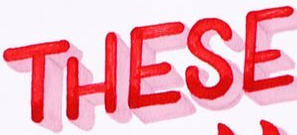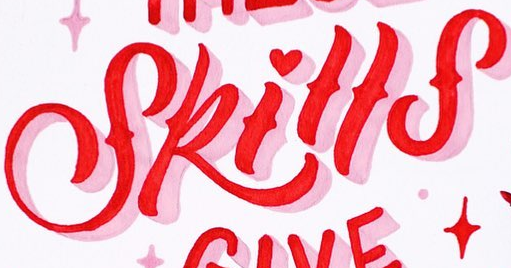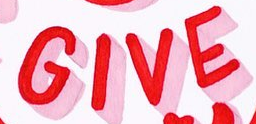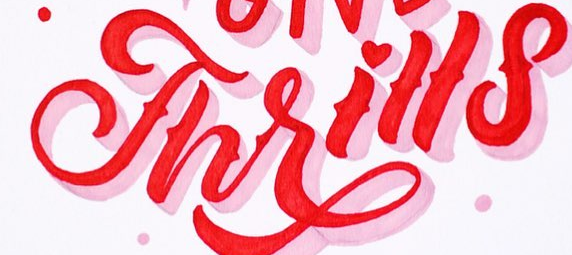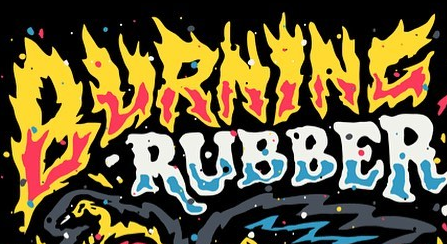What text is displayed in these images sequentially, separated by a semicolon? THESE; Skills; GIVE; Thrills; BURNINC 